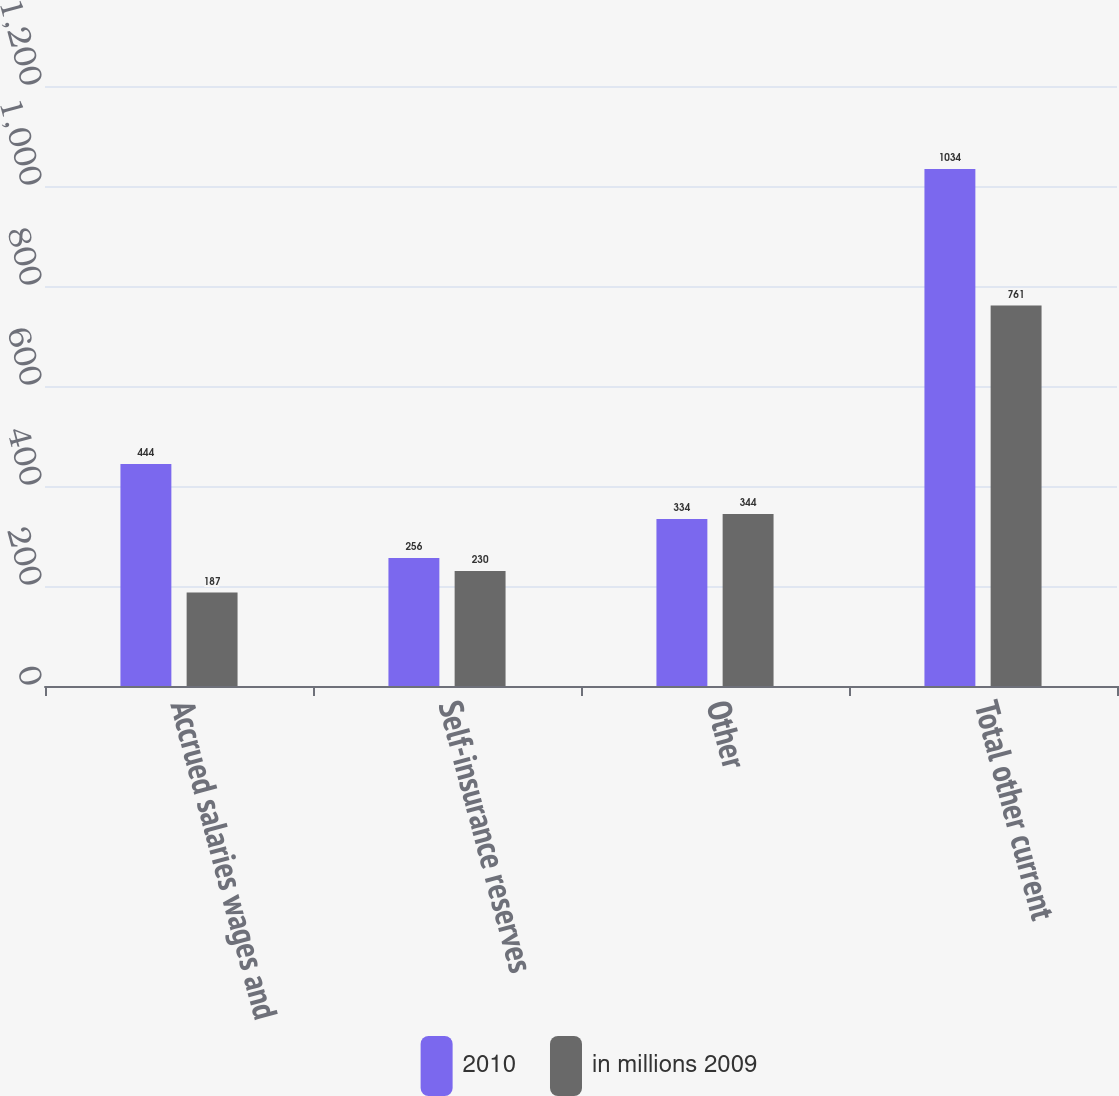Convert chart to OTSL. <chart><loc_0><loc_0><loc_500><loc_500><stacked_bar_chart><ecel><fcel>Accrued salaries wages and<fcel>Self-insurance reserves<fcel>Other<fcel>Total other current<nl><fcel>2010<fcel>444<fcel>256<fcel>334<fcel>1034<nl><fcel>in millions 2009<fcel>187<fcel>230<fcel>344<fcel>761<nl></chart> 